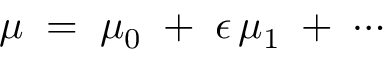Convert formula to latex. <formula><loc_0><loc_0><loc_500><loc_500>\mu \, = \, \mu _ { 0 } \, + \, \epsilon \, \mu _ { 1 } \, + \, \cdots</formula> 